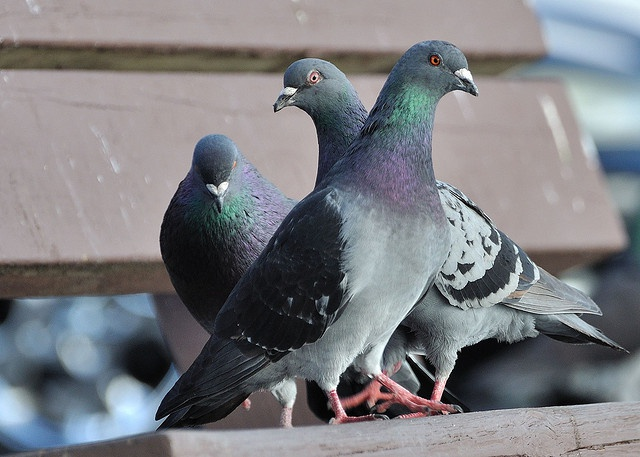Describe the objects in this image and their specific colors. I can see bench in darkgray, gray, and black tones, bird in darkgray, black, and gray tones, bird in darkgray, gray, black, and lightgray tones, and bird in darkgray, black, and gray tones in this image. 